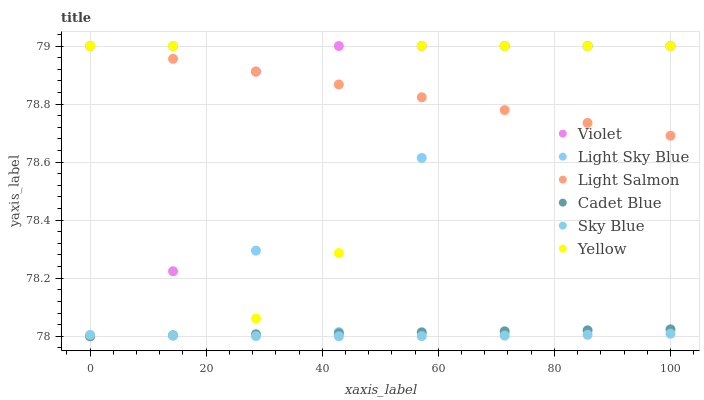Does Sky Blue have the minimum area under the curve?
Answer yes or no. Yes. Does Light Salmon have the maximum area under the curve?
Answer yes or no. Yes. Does Cadet Blue have the minimum area under the curve?
Answer yes or no. No. Does Cadet Blue have the maximum area under the curve?
Answer yes or no. No. Is Light Salmon the smoothest?
Answer yes or no. Yes. Is Yellow the roughest?
Answer yes or no. Yes. Is Cadet Blue the smoothest?
Answer yes or no. No. Is Cadet Blue the roughest?
Answer yes or no. No. Does Cadet Blue have the lowest value?
Answer yes or no. Yes. Does Yellow have the lowest value?
Answer yes or no. No. Does Violet have the highest value?
Answer yes or no. Yes. Does Cadet Blue have the highest value?
Answer yes or no. No. Is Cadet Blue less than Light Sky Blue?
Answer yes or no. Yes. Is Light Salmon greater than Cadet Blue?
Answer yes or no. Yes. Does Light Salmon intersect Yellow?
Answer yes or no. Yes. Is Light Salmon less than Yellow?
Answer yes or no. No. Is Light Salmon greater than Yellow?
Answer yes or no. No. Does Cadet Blue intersect Light Sky Blue?
Answer yes or no. No. 